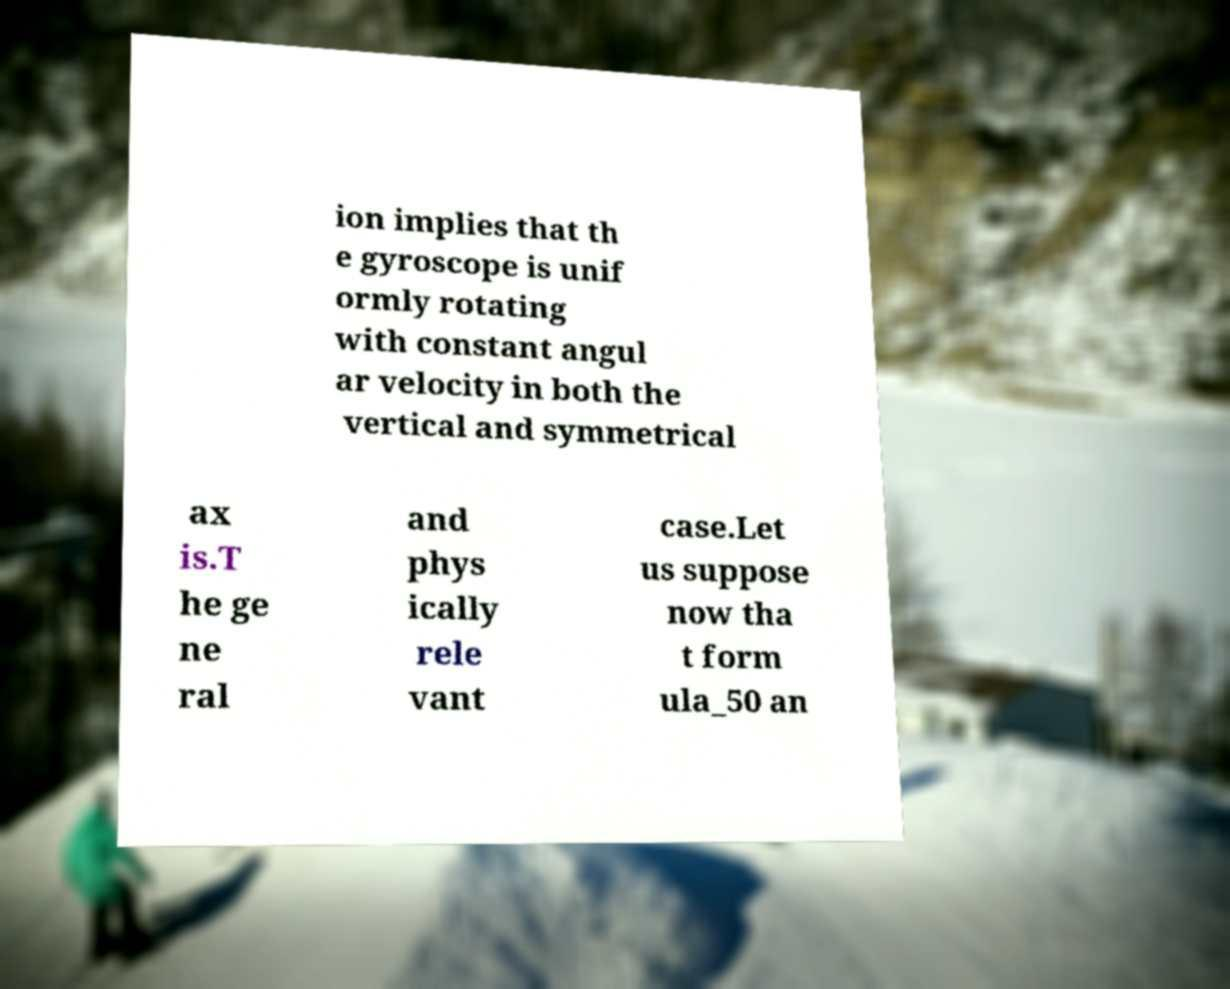I need the written content from this picture converted into text. Can you do that? ion implies that th e gyroscope is unif ormly rotating with constant angul ar velocity in both the vertical and symmetrical ax is.T he ge ne ral and phys ically rele vant case.Let us suppose now tha t form ula_50 an 